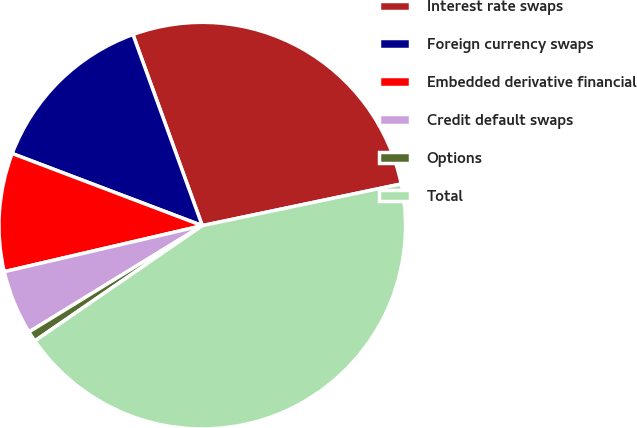Convert chart to OTSL. <chart><loc_0><loc_0><loc_500><loc_500><pie_chart><fcel>Interest rate swaps<fcel>Foreign currency swaps<fcel>Embedded derivative financial<fcel>Credit default swaps<fcel>Options<fcel>Total<nl><fcel>27.25%<fcel>13.69%<fcel>9.41%<fcel>5.12%<fcel>0.84%<fcel>43.69%<nl></chart> 